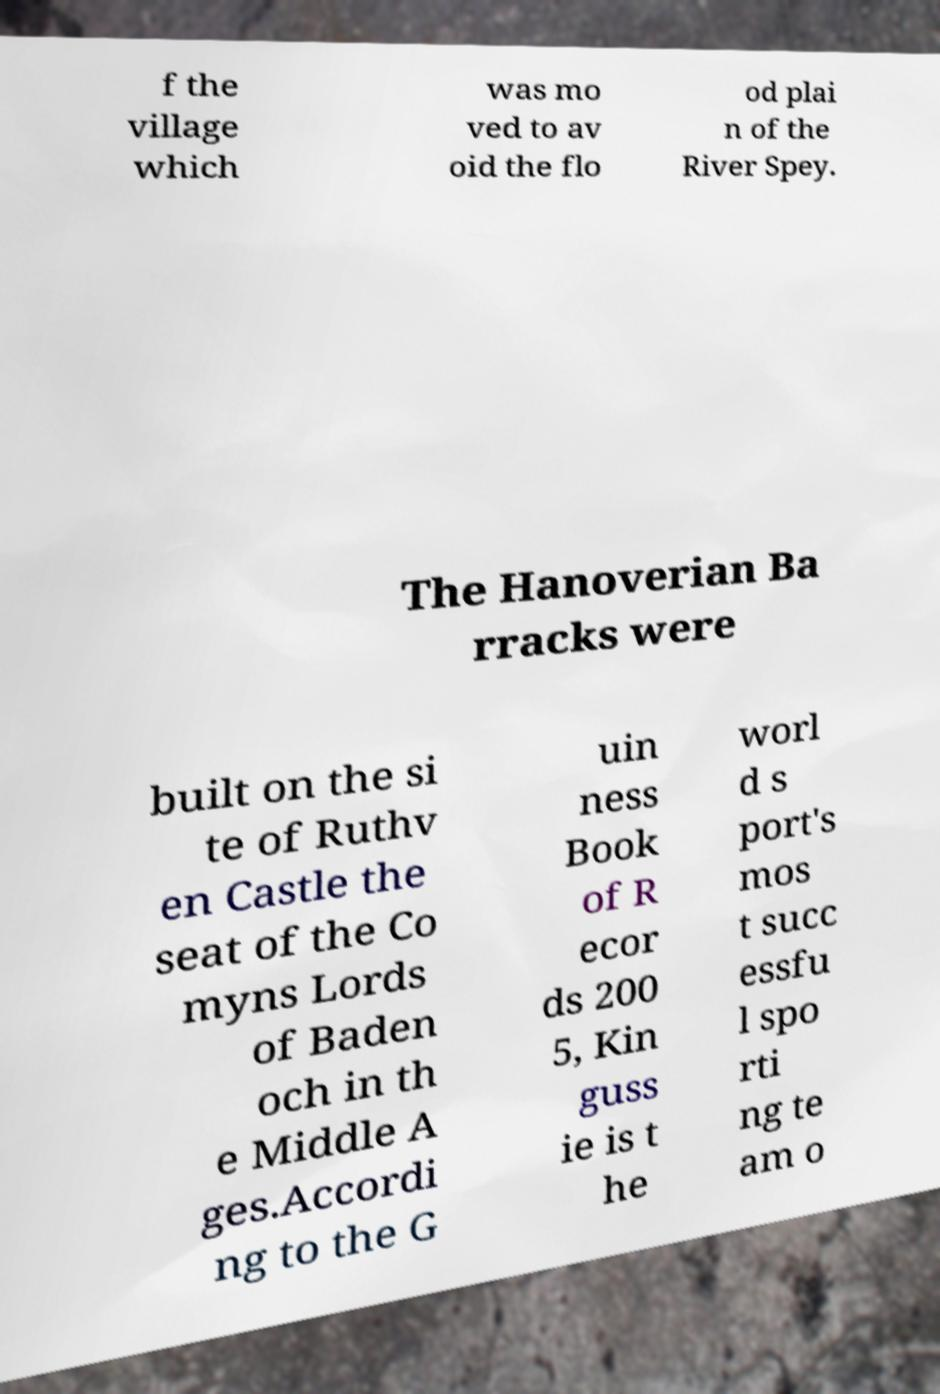For documentation purposes, I need the text within this image transcribed. Could you provide that? f the village which was mo ved to av oid the flo od plai n of the River Spey. The Hanoverian Ba rracks were built on the si te of Ruthv en Castle the seat of the Co myns Lords of Baden och in th e Middle A ges.Accordi ng to the G uin ness Book of R ecor ds 200 5, Kin guss ie is t he worl d s port's mos t succ essfu l spo rti ng te am o 